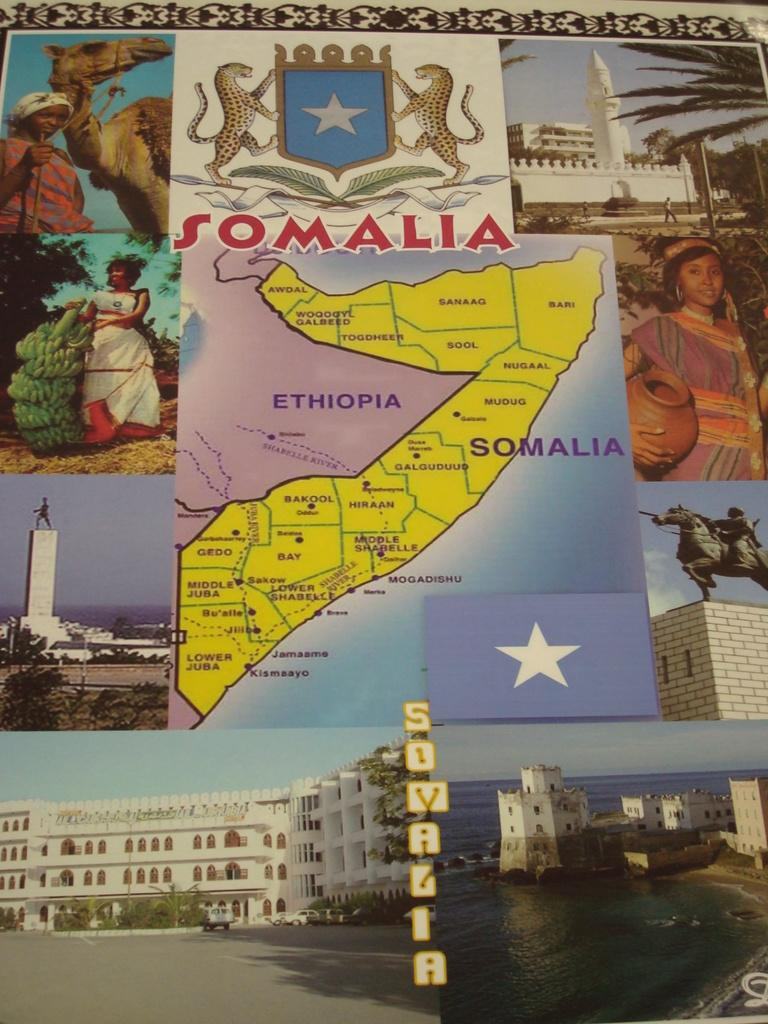<image>
Provide a brief description of the given image. Somalia and Ethiopia are shown on a map of the region. 